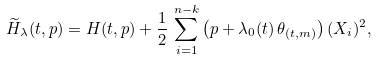<formula> <loc_0><loc_0><loc_500><loc_500>\widetilde { H } _ { \lambda } ( t , p ) = H ( t , p ) + \frac { 1 } { 2 } \, \sum _ { i = 1 } ^ { n - k } \left ( p + \lambda _ { 0 } ( t ) \, \theta _ { ( t , m ) } \right ) ( X _ { i } ) ^ { 2 } ,</formula> 